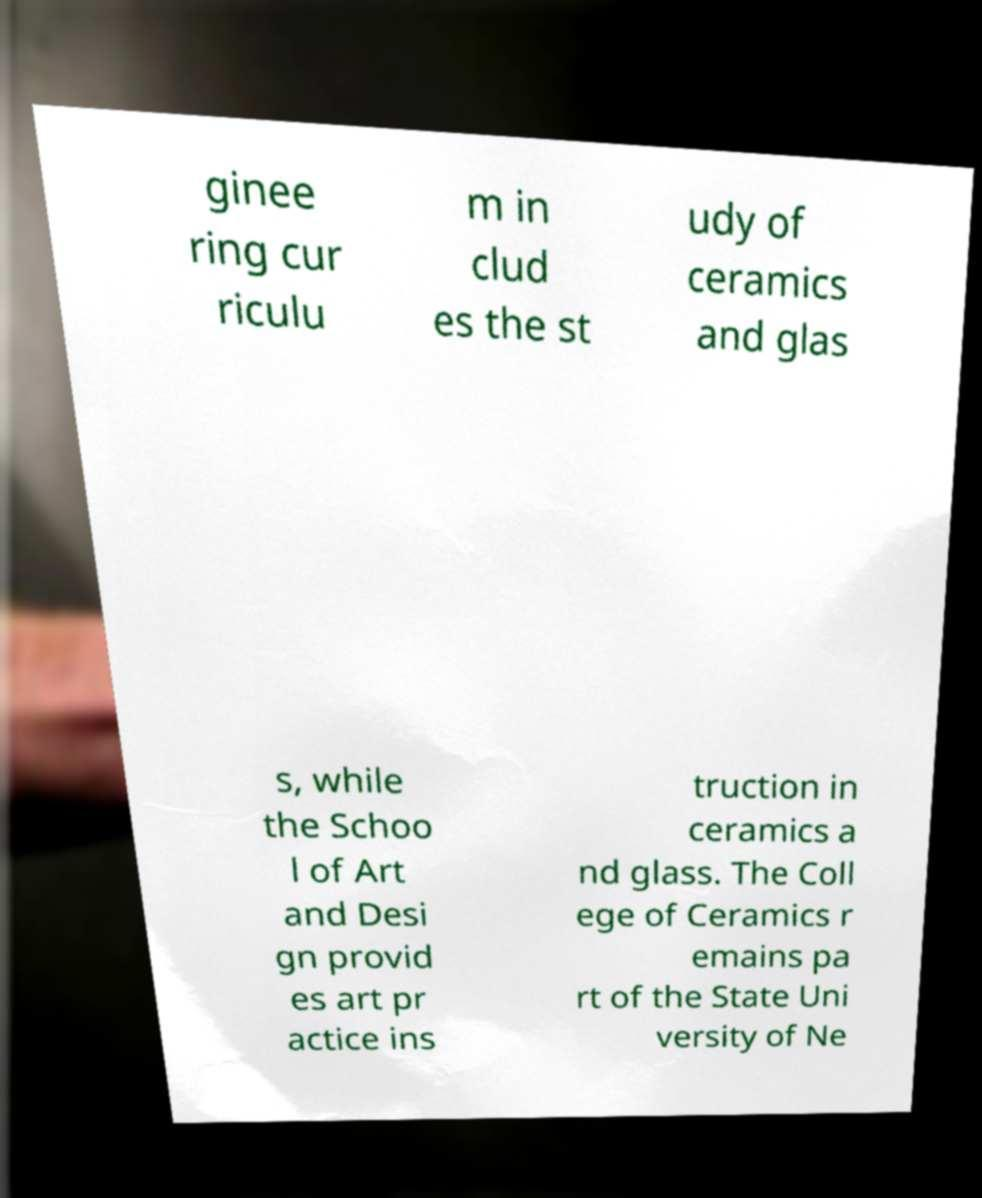Can you read and provide the text displayed in the image?This photo seems to have some interesting text. Can you extract and type it out for me? ginee ring cur riculu m in clud es the st udy of ceramics and glas s, while the Schoo l of Art and Desi gn provid es art pr actice ins truction in ceramics a nd glass. The Coll ege of Ceramics r emains pa rt of the State Uni versity of Ne 